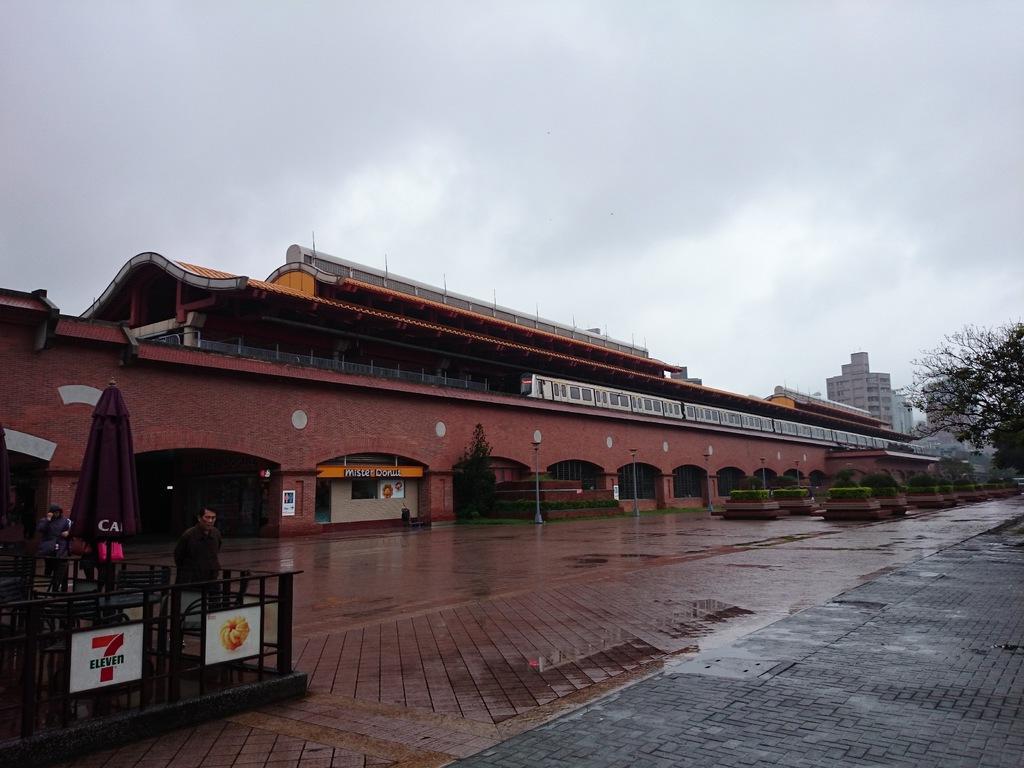Please provide a concise description of this image. In this image we can see a building with a train on it. To the left side of the image we can see a person standing and an umbrella, metal barricade. To the right side of the image we can see group of plants, tree, building and in the background we can see the cloudy sky. 